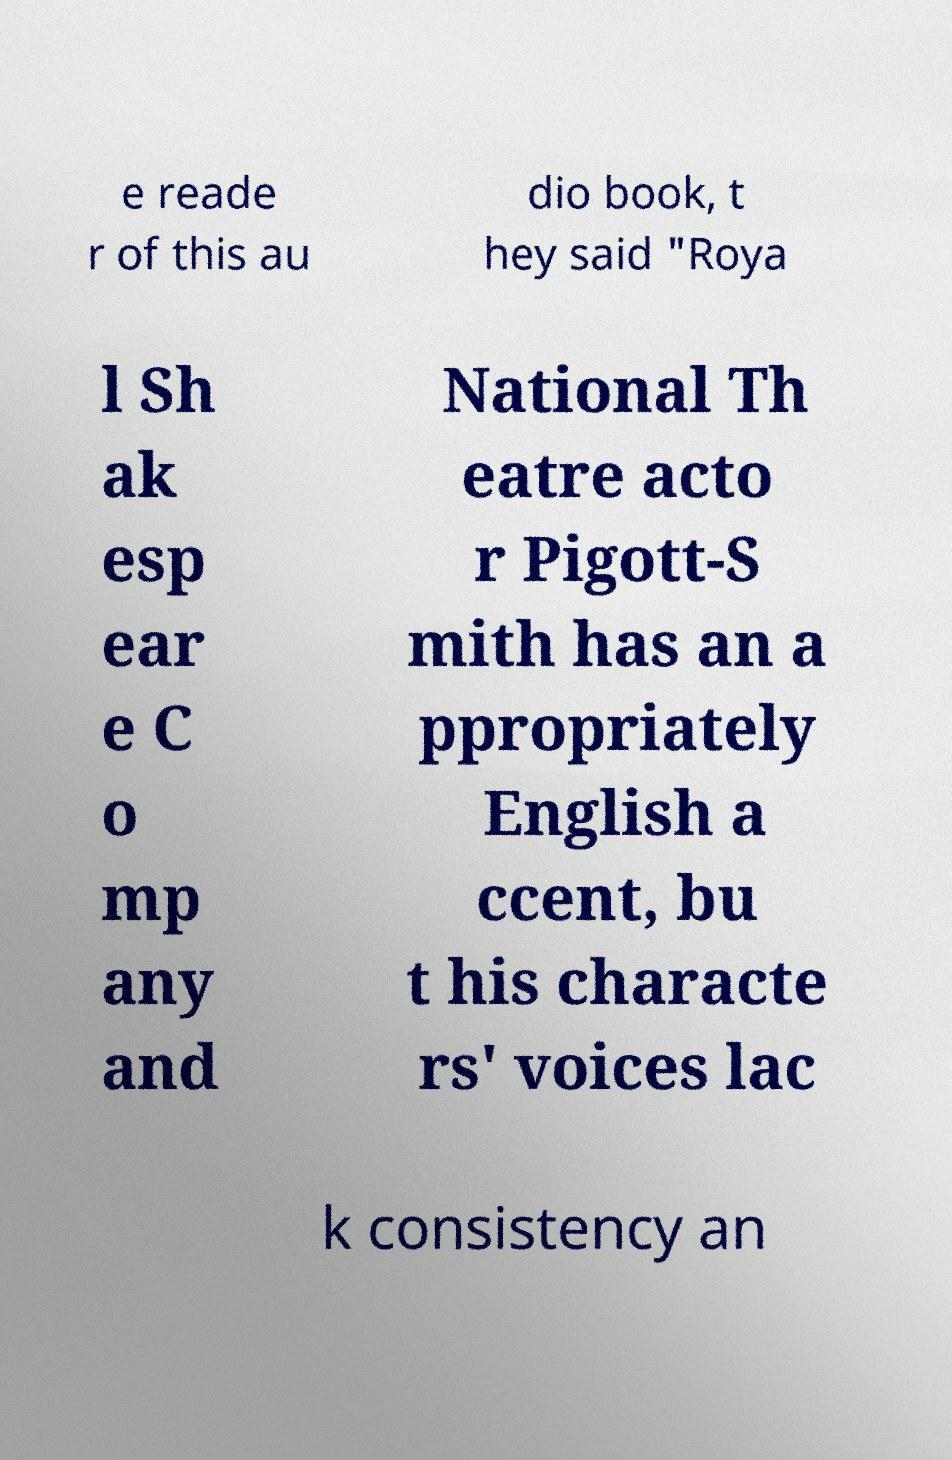I need the written content from this picture converted into text. Can you do that? e reade r of this au dio book, t hey said "Roya l Sh ak esp ear e C o mp any and National Th eatre acto r Pigott-S mith has an a ppropriately English a ccent, bu t his characte rs' voices lac k consistency an 